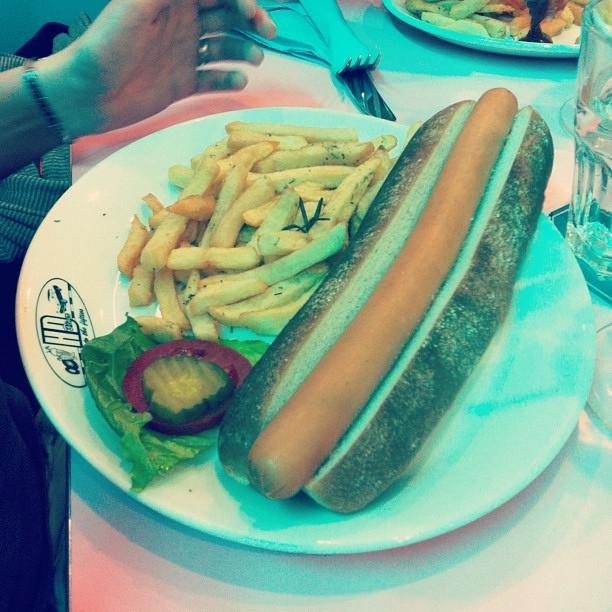Describe the objects in this image and their specific colors. I can see hot dog in teal, tan, and lightgreen tones, dining table in teal, beige, darkgray, and lightpink tones, people in teal, gray, and navy tones, dining table in teal, turquoise, aquamarine, and beige tones, and cup in teal, turquoise, and darkgray tones in this image. 